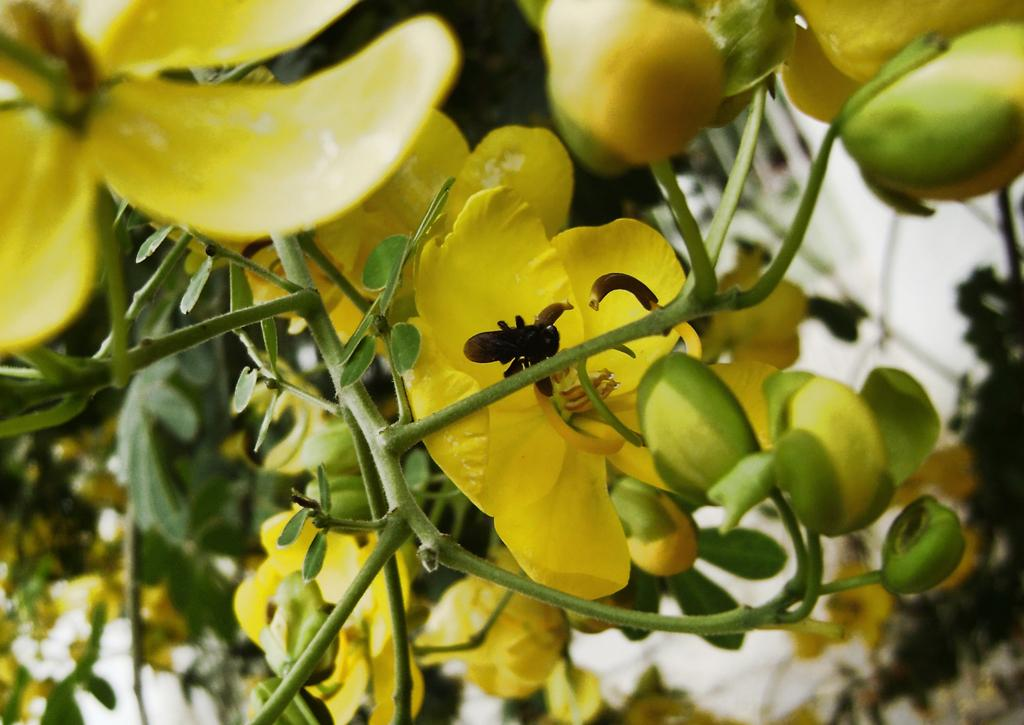What type of plant can be seen in the image? There is a tree in the image. What color are the flowers on the tree? The flowers on the tree are yellow. What stage of growth are the flowers in? The tree has buds, which suggests that the flowers are in the early stages of blooming. Can you describe any other living organisms present in the image? Yes, there is an insect crawling on a branch of the tree. What type of stage can be seen in the image? There is no stage present in the image; it features a tree with yellow flowers and an insect. 